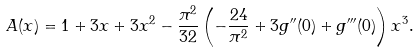Convert formula to latex. <formula><loc_0><loc_0><loc_500><loc_500>A ( x ) = 1 + 3 x + 3 x ^ { 2 } - \frac { \pi ^ { 2 } } { 3 2 } \left ( - \frac { 2 4 } { \pi ^ { 2 } } + 3 g ^ { \prime \prime } ( 0 ) + g ^ { \prime \prime \prime } ( 0 ) \right ) x ^ { 3 } .</formula> 